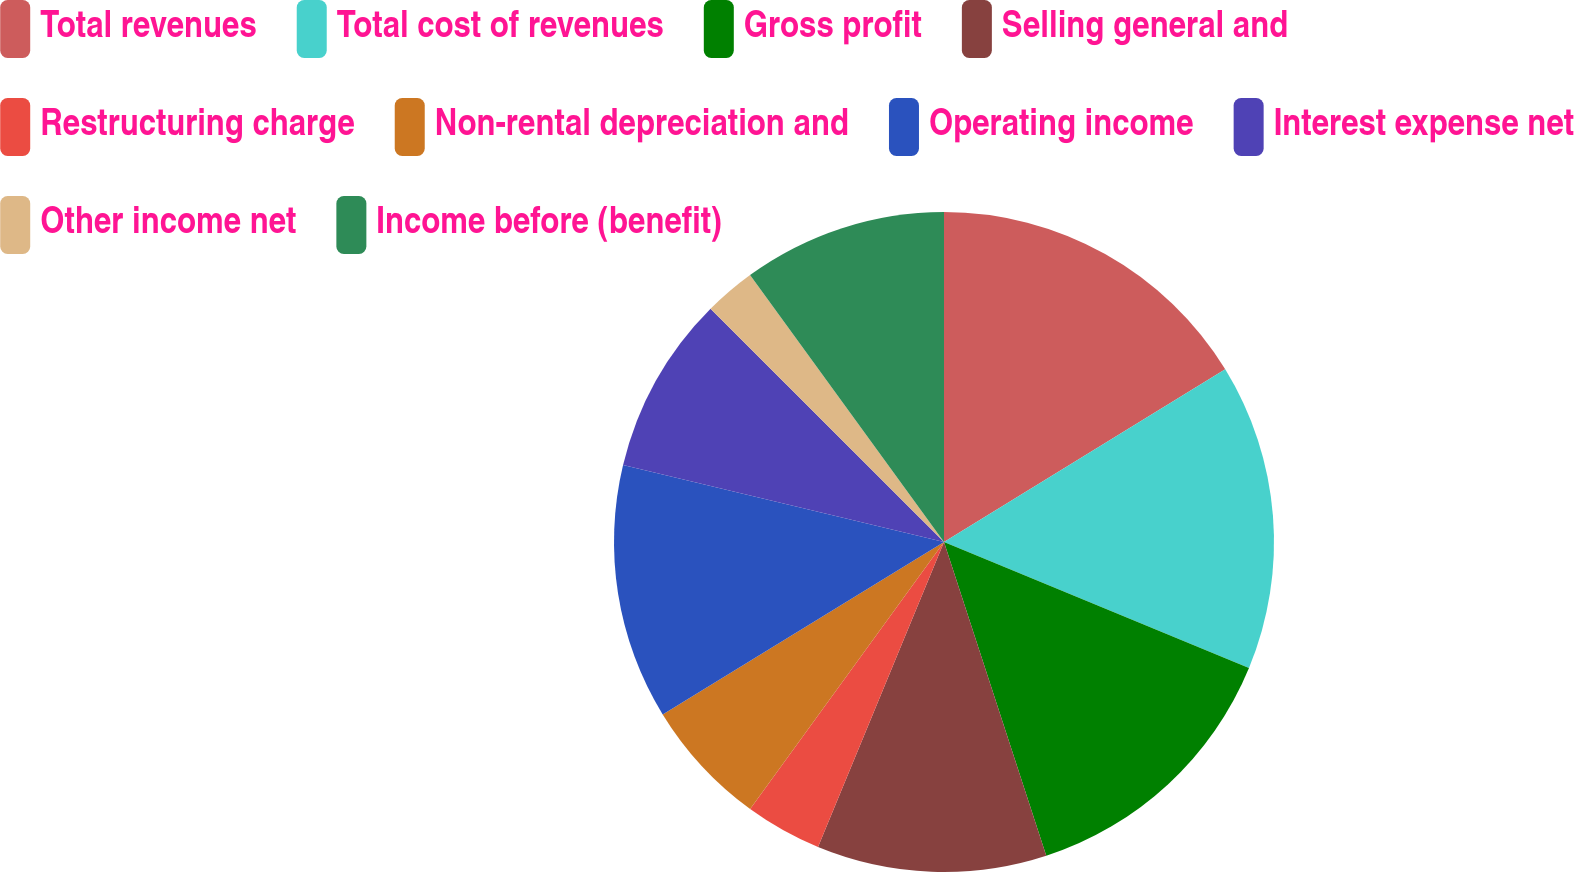Convert chart to OTSL. <chart><loc_0><loc_0><loc_500><loc_500><pie_chart><fcel>Total revenues<fcel>Total cost of revenues<fcel>Gross profit<fcel>Selling general and<fcel>Restructuring charge<fcel>Non-rental depreciation and<fcel>Operating income<fcel>Interest expense net<fcel>Other income net<fcel>Income before (benefit)<nl><fcel>16.24%<fcel>15.0%<fcel>13.75%<fcel>11.25%<fcel>3.76%<fcel>6.25%<fcel>12.5%<fcel>8.75%<fcel>2.51%<fcel>10.0%<nl></chart> 